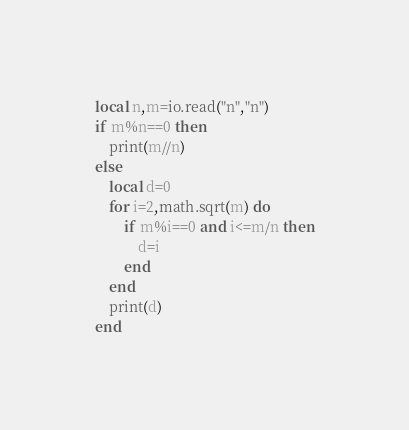Convert code to text. <code><loc_0><loc_0><loc_500><loc_500><_Lua_>local n,m=io.read("n","n")
if m%n==0 then
    print(m//n)
else
    local d=0
    for i=2,math.sqrt(m) do
        if m%i==0 and i<=m/n then
            d=i
        end
    end
    print(d)
end</code> 